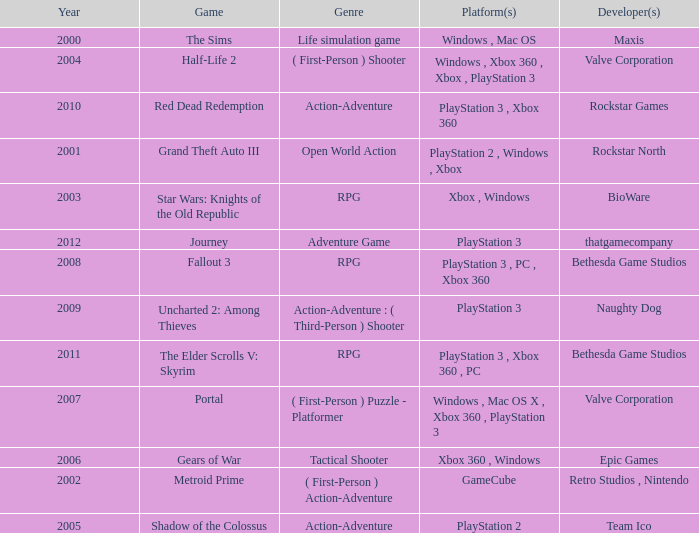What game was in 2001? Grand Theft Auto III. 